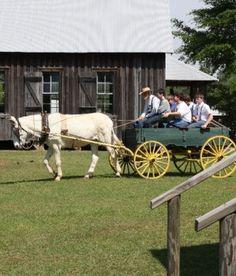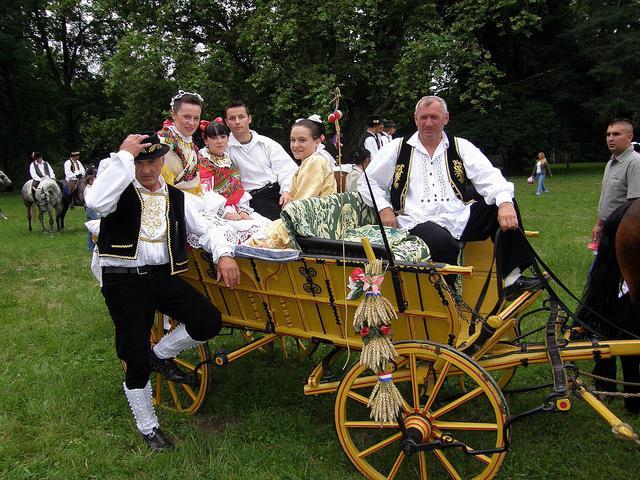The first image is the image on the left, the second image is the image on the right. Examine the images to the left and right. Is the description "At least one image shows a cart pulled by exactly two white horses." accurate? Answer yes or no. No. The first image is the image on the left, the second image is the image on the right. Given the left and right images, does the statement "There are two white horses in the image on the left." hold true? Answer yes or no. No. 